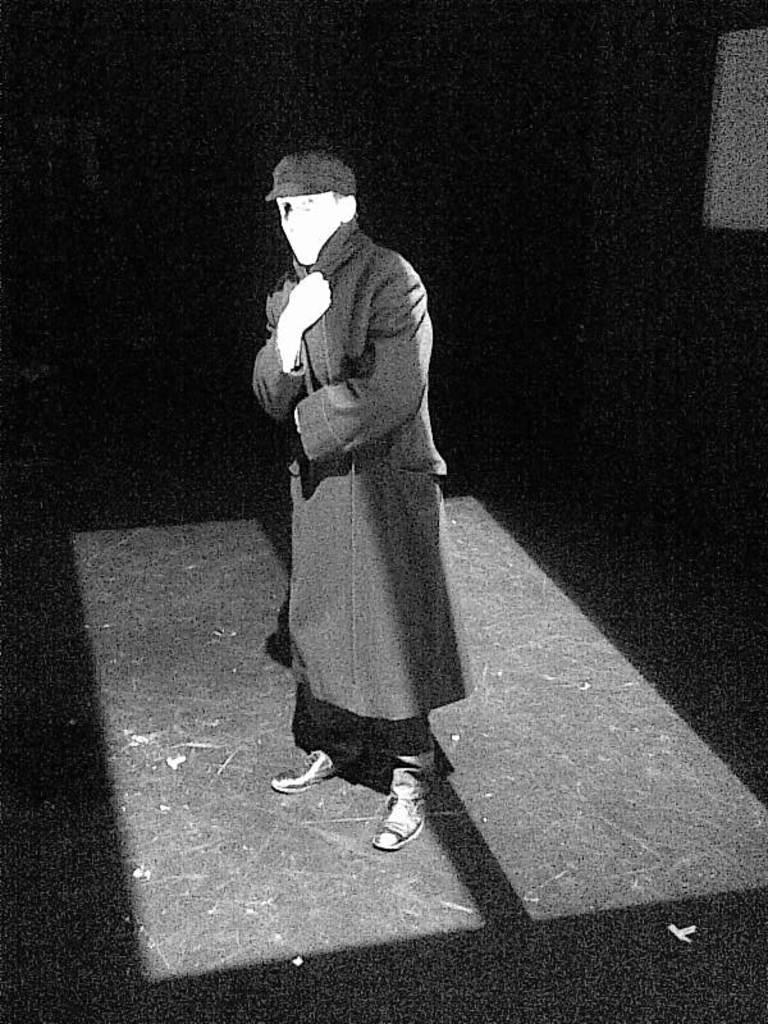Who or what is present in the image? There is a person in the image. What can be seen beneath the person's feet? The ground is visible in the image. How would you describe the overall lighting in the image? The background of the image is dark. What is located on the right side of the image? There is an object on the right side of the image. What type of grass is growing on the memory in the image? There is no memory or grass present in the image. 